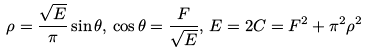Convert formula to latex. <formula><loc_0><loc_0><loc_500><loc_500>\rho = \frac { \sqrt { E } } { \pi } \sin \theta , \, \cos \theta = \frac { F } { \sqrt { E } } , \, E = 2 C = F ^ { 2 } + \pi ^ { 2 } \rho ^ { 2 }</formula> 